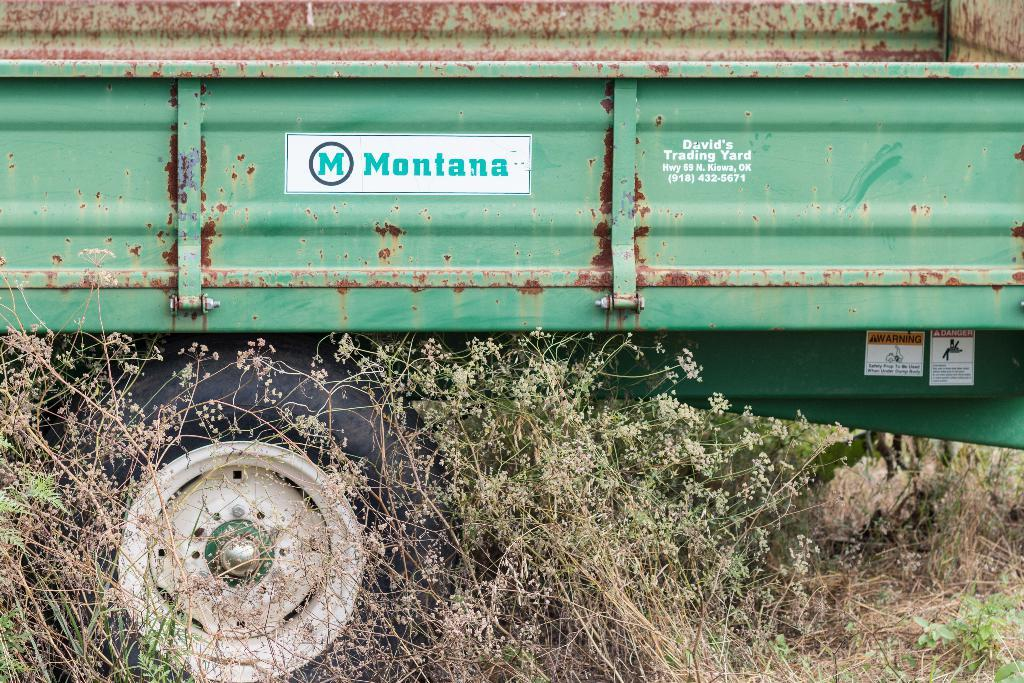What type of vehicle is in the image? There is a truck in the image. What color is the truck? The truck is green in color. How many wheels are on the truck? There is at least one wheel visible on the truck. What type of vegetation can be seen in the image? Plants and grass are visible in the image. Are there any decorations on the truck? Yes, there are stickers attached to the truck. What type of care does the lawyer provide for the truck in the image? There is no lawyer present in the image, and therefore no care is being provided for the truck. 